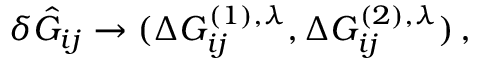Convert formula to latex. <formula><loc_0><loc_0><loc_500><loc_500>\begin{array} { r } { \delta \hat { G } _ { i j } \rightarrow ( \Delta G _ { i j } ^ { ( 1 ) , \lambda } , \Delta G _ { i j } ^ { ( 2 ) , \lambda } ) \, , } \end{array}</formula> 